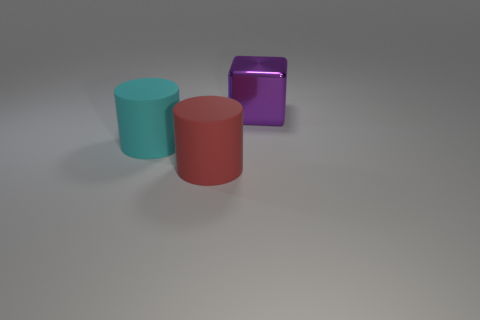Add 1 small blue metal balls. How many objects exist? 4 Subtract all cylinders. How many objects are left? 1 Add 1 purple things. How many purple things are left? 2 Add 3 big purple metal things. How many big purple metal things exist? 4 Subtract 0 gray balls. How many objects are left? 3 Subtract all large matte objects. Subtract all big purple cubes. How many objects are left? 0 